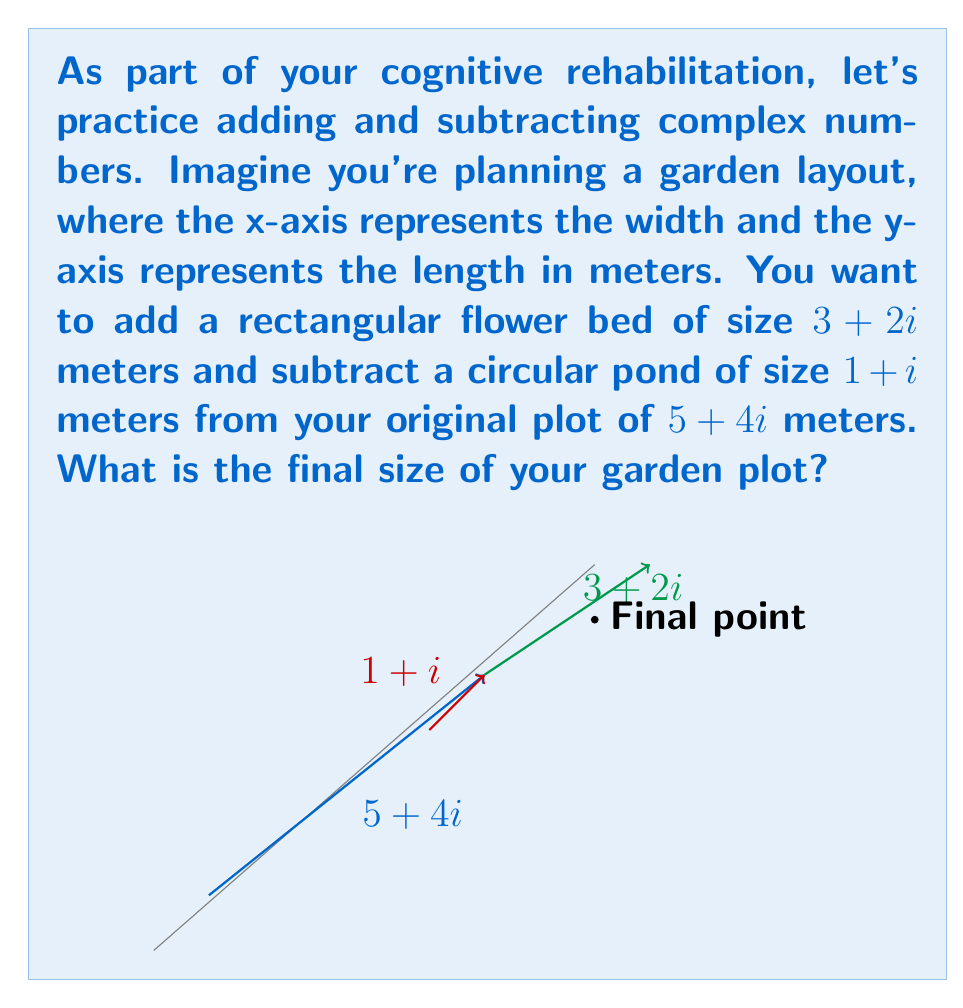Teach me how to tackle this problem. Let's approach this step-by-step:

1) We start with the original plot size: $5 + 4i$

2) We need to add the flower bed: $3 + 2i$
   $$(5 + 4i) + (3 + 2i)$$
   
   To add complex numbers, we add the real and imaginary parts separately:
   $$(5 + 3) + (4 + 2)i = 8 + 6i$$

3) Now we need to subtract the pond: $1 + i$
   $$(8 + 6i) - (1 + i)$$
   
   To subtract complex numbers, we subtract the real and imaginary parts separately:
   $$(8 - 1) + (6 - 1)i = 7 + 5i$$

Therefore, the final size of the garden plot is $7 + 5i$ meters.
Answer: $7 + 5i$ meters 